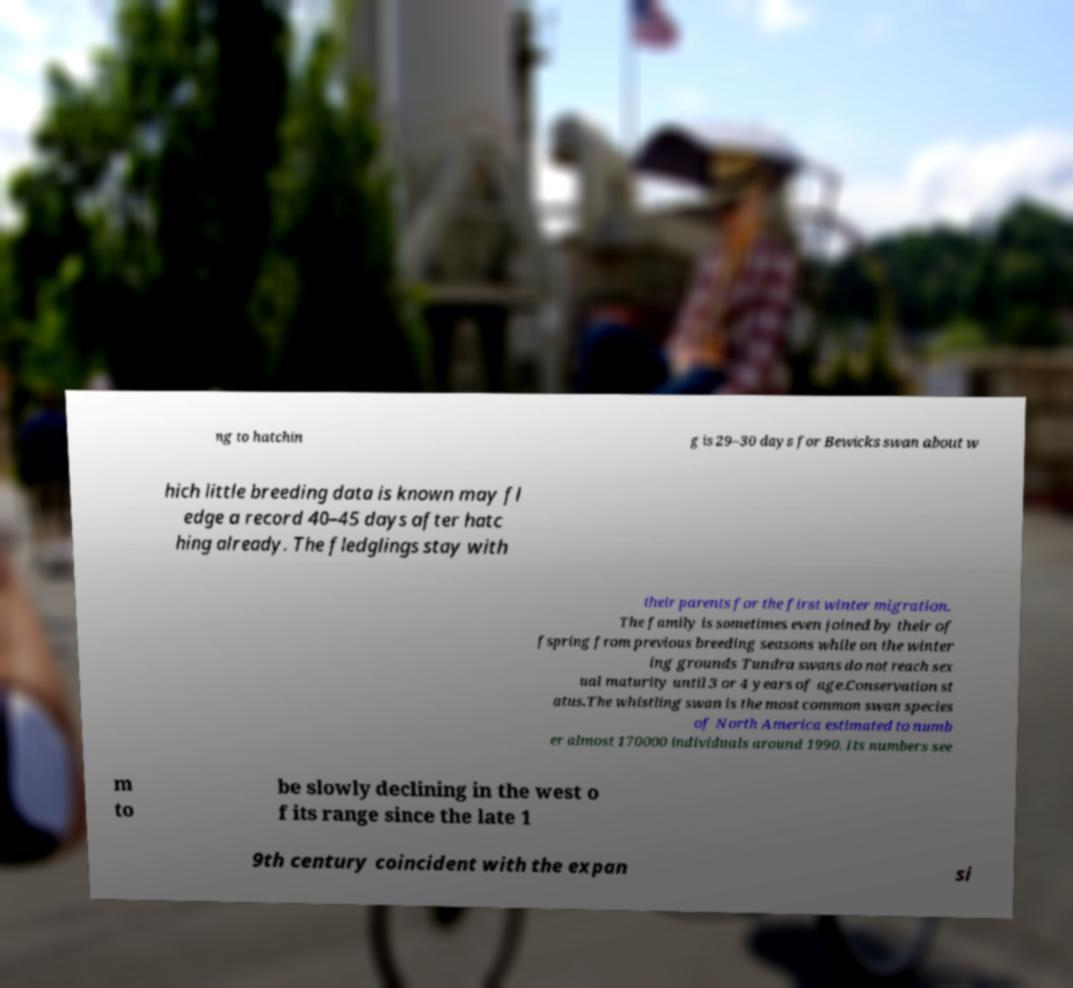Could you assist in decoding the text presented in this image and type it out clearly? ng to hatchin g is 29–30 days for Bewicks swan about w hich little breeding data is known may fl edge a record 40–45 days after hatc hing already. The fledglings stay with their parents for the first winter migration. The family is sometimes even joined by their of fspring from previous breeding seasons while on the winter ing grounds Tundra swans do not reach sex ual maturity until 3 or 4 years of age.Conservation st atus.The whistling swan is the most common swan species of North America estimated to numb er almost 170000 individuals around 1990. Its numbers see m to be slowly declining in the west o f its range since the late 1 9th century coincident with the expan si 